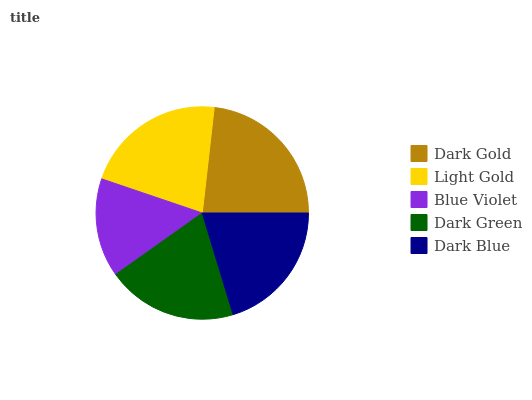Is Blue Violet the minimum?
Answer yes or no. Yes. Is Dark Gold the maximum?
Answer yes or no. Yes. Is Light Gold the minimum?
Answer yes or no. No. Is Light Gold the maximum?
Answer yes or no. No. Is Dark Gold greater than Light Gold?
Answer yes or no. Yes. Is Light Gold less than Dark Gold?
Answer yes or no. Yes. Is Light Gold greater than Dark Gold?
Answer yes or no. No. Is Dark Gold less than Light Gold?
Answer yes or no. No. Is Dark Blue the high median?
Answer yes or no. Yes. Is Dark Blue the low median?
Answer yes or no. Yes. Is Blue Violet the high median?
Answer yes or no. No. Is Light Gold the low median?
Answer yes or no. No. 